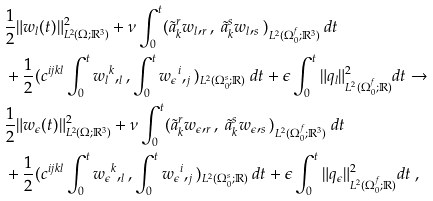Convert formula to latex. <formula><loc_0><loc_0><loc_500><loc_500>& \frac { 1 } { 2 } \| { w _ { l } } ( t ) \| ^ { 2 } _ { L ^ { 2 } ( \Omega ; { \mathbb { R } } ^ { 3 } ) } + \nu \int _ { 0 } ^ { t } ( \tilde { a } _ { k } ^ { r } { w _ { l } } , _ { r } , \ \tilde { a } _ { k } ^ { s } { w _ { l } } , _ { s } ) _ { L ^ { 2 } ( \Omega _ { 0 } ^ { f } ; { \mathbb { R } } ^ { 3 } ) } \ d t \\ & + \frac { 1 } { 2 } ( c ^ { i j k l } \int _ { 0 } ^ { t } { w _ { l } } ^ { k } , _ { l } , \int _ { 0 } ^ { t } { w _ { \epsilon } } ^ { i } , _ { j } ) _ { L ^ { 2 } ( \Omega _ { 0 } ^ { s } ; { \mathbb { R } } ) } \ d t + \epsilon \int _ { 0 } ^ { t } \| q _ { l } \| ^ { 2 } _ { L ^ { 2 } ( \Omega _ { 0 } ^ { f } ; { \mathbb { R } } ) } d t \rightarrow \\ & \frac { 1 } { 2 } \| { w _ { \epsilon } } ( t ) \| ^ { 2 } _ { L ^ { 2 } ( \Omega ; { \mathbb { R } } ^ { 3 } ) } + \nu \int _ { 0 } ^ { t } ( \tilde { a } _ { k } ^ { r } { w _ { \epsilon } } , _ { r } , \ \tilde { a } _ { k } ^ { s } { w _ { \epsilon } } , _ { s } ) _ { L ^ { 2 } ( \Omega _ { 0 } ^ { f } ; { \mathbb { R } } ^ { 3 } ) } \ d t \\ & + \frac { 1 } { 2 } ( c ^ { i j k l } \int _ { 0 } ^ { t } { w _ { \epsilon } } ^ { k } , _ { l } , \int _ { 0 } ^ { t } { w _ { \epsilon } } ^ { i } , _ { j } ) _ { L ^ { 2 } ( \Omega _ { 0 } ^ { s } ; { \mathbb { R } } ) } \ d t + \epsilon \int _ { 0 } ^ { t } \| q _ { \epsilon } \| ^ { 2 } _ { L ^ { 2 } ( \Omega _ { 0 } ^ { f } ; { \mathbb { R } } ) } d t \ ,</formula> 